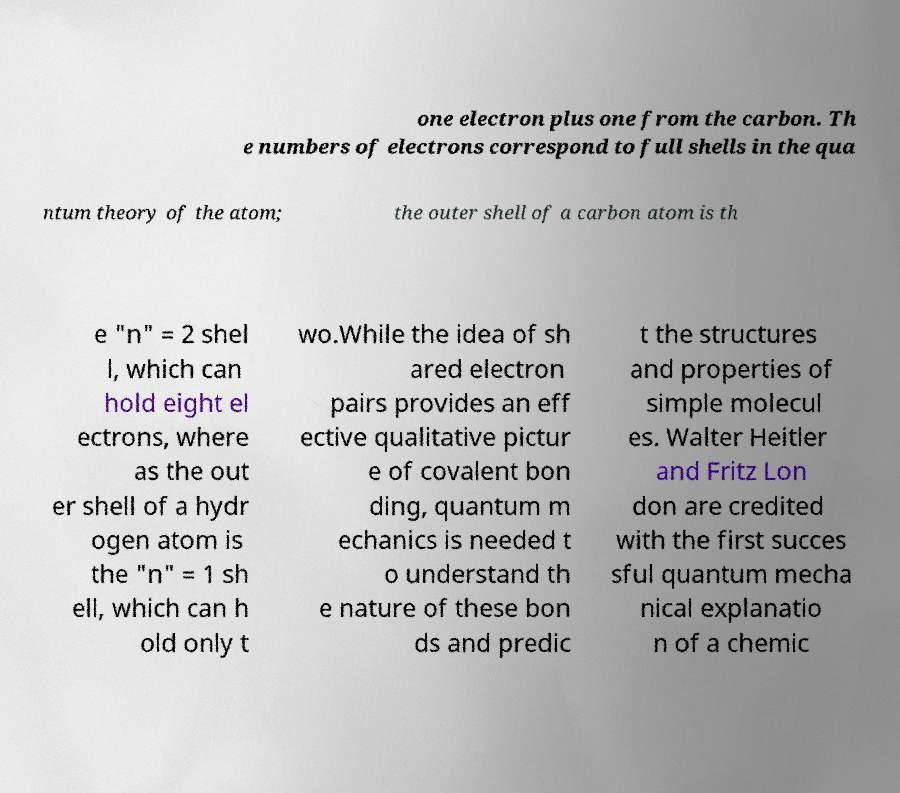There's text embedded in this image that I need extracted. Can you transcribe it verbatim? one electron plus one from the carbon. Th e numbers of electrons correspond to full shells in the qua ntum theory of the atom; the outer shell of a carbon atom is th e "n" = 2 shel l, which can hold eight el ectrons, where as the out er shell of a hydr ogen atom is the "n" = 1 sh ell, which can h old only t wo.While the idea of sh ared electron pairs provides an eff ective qualitative pictur e of covalent bon ding, quantum m echanics is needed t o understand th e nature of these bon ds and predic t the structures and properties of simple molecul es. Walter Heitler and Fritz Lon don are credited with the first succes sful quantum mecha nical explanatio n of a chemic 